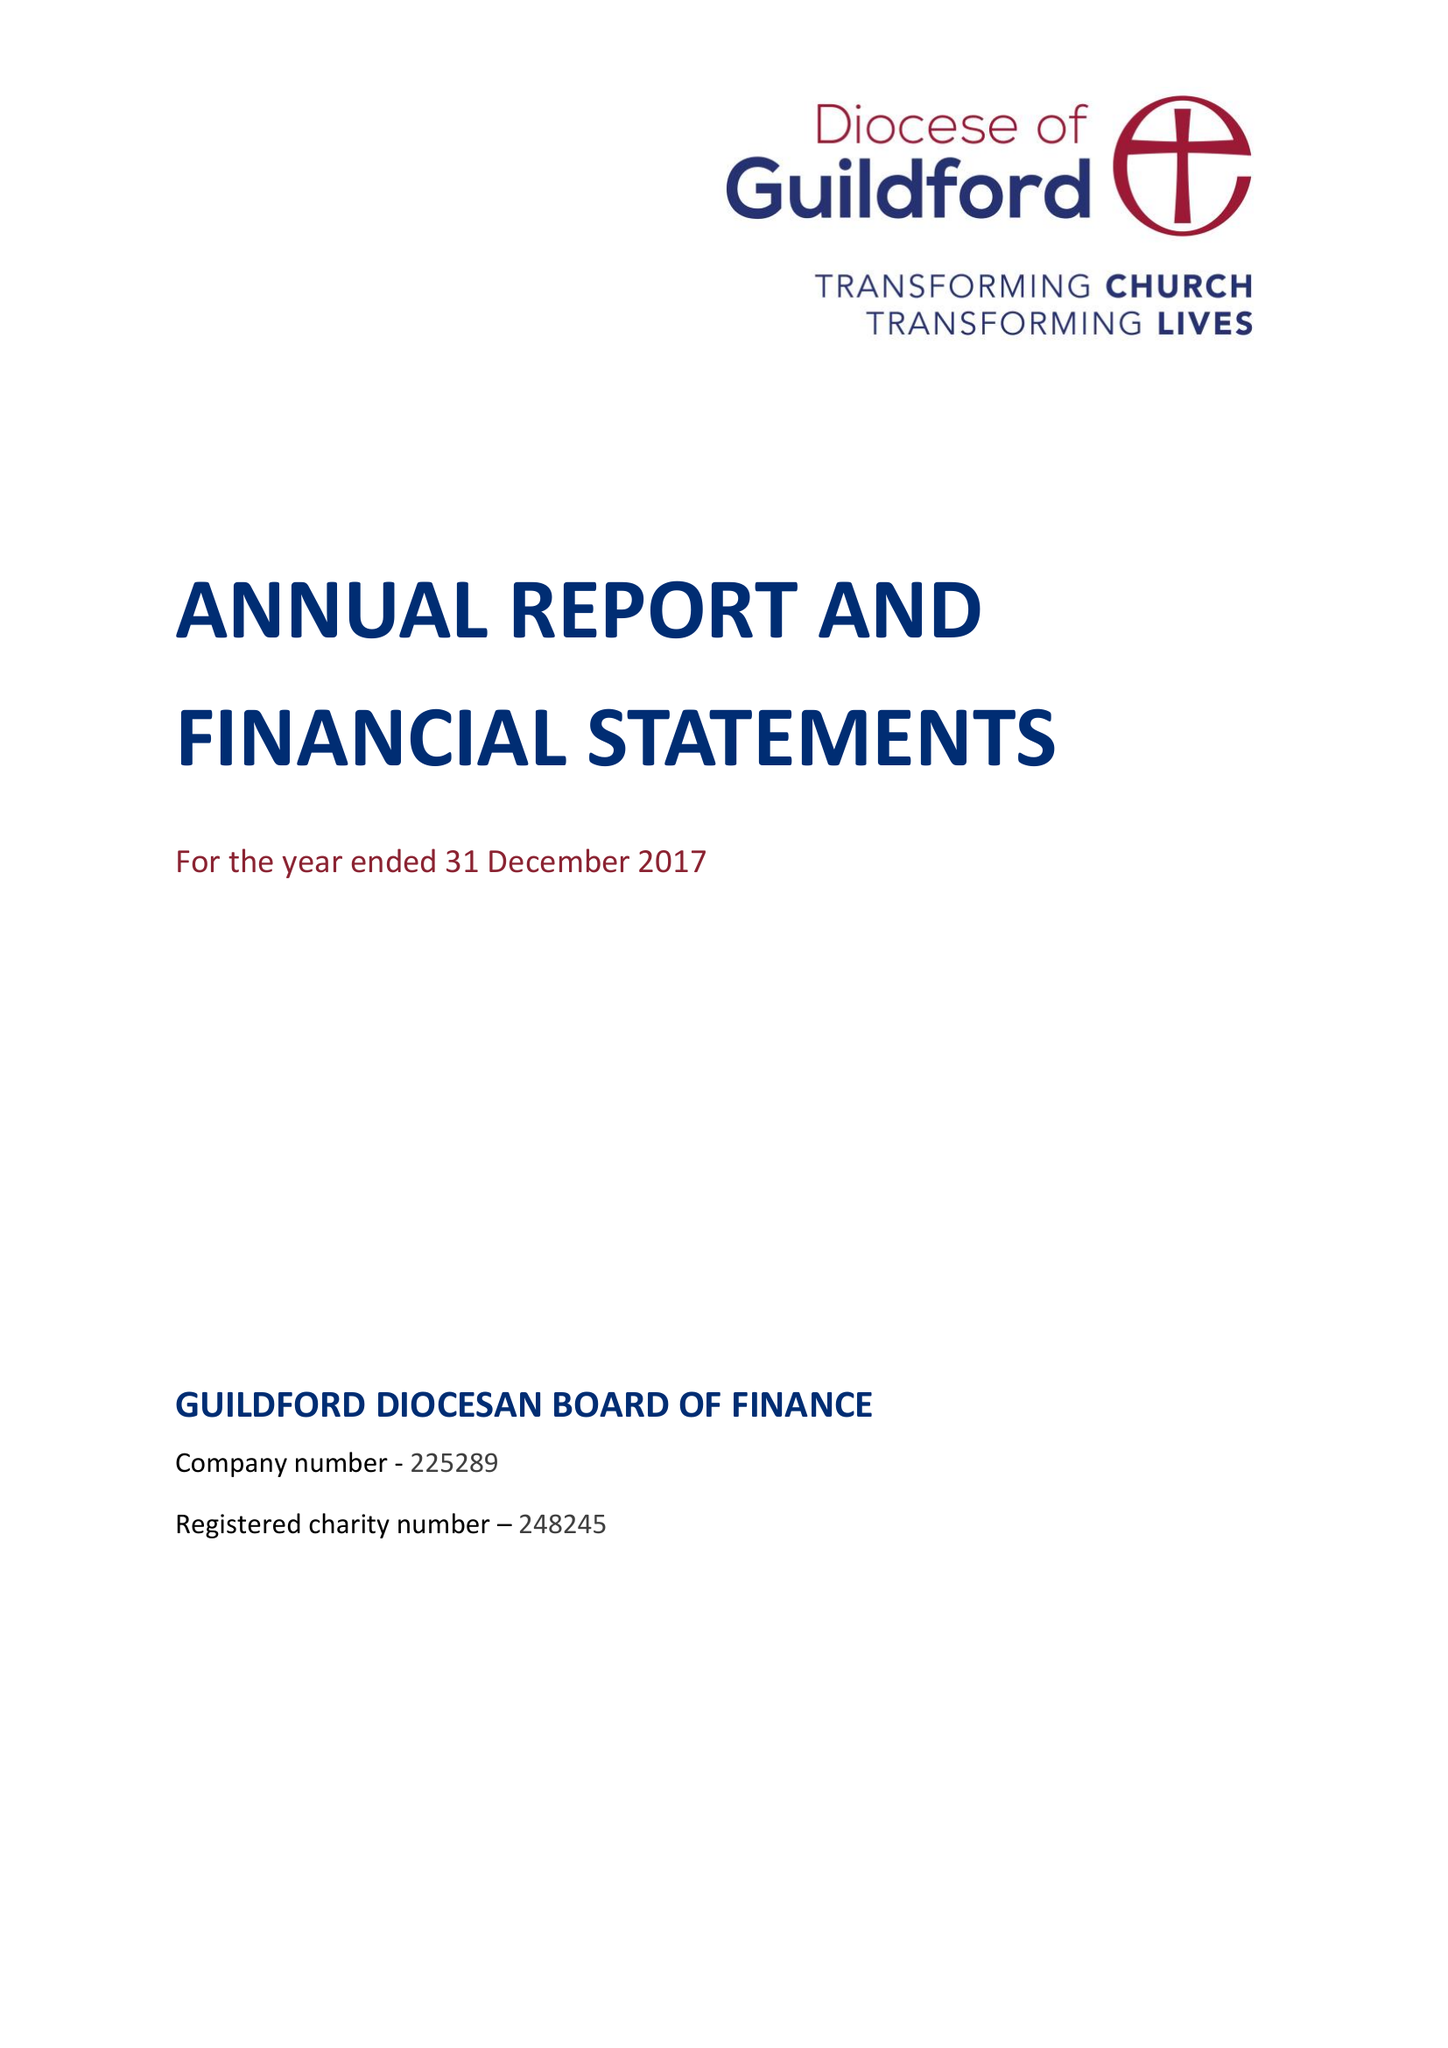What is the value for the charity_name?
Answer the question using a single word or phrase. Guildford Diocesan Board Of Finance 